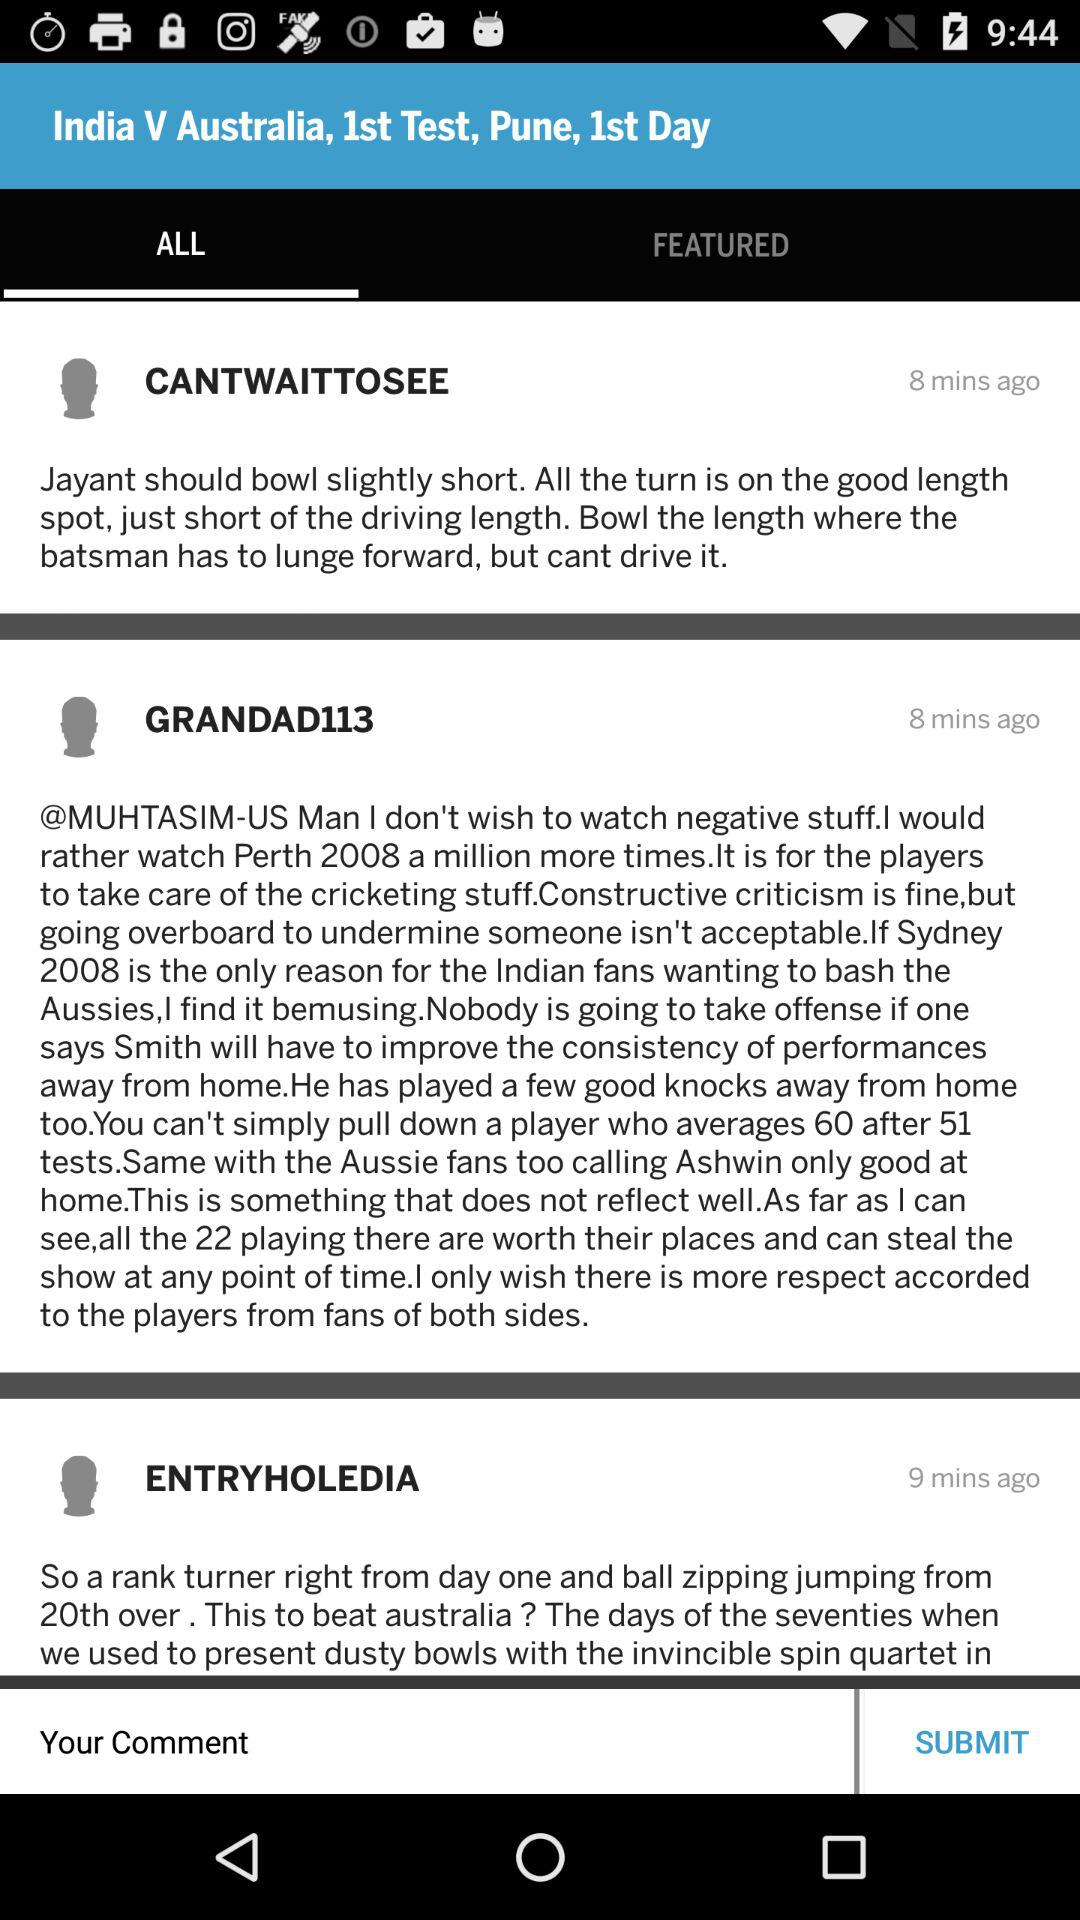What is the profile name?
When the provided information is insufficient, respond with <no answer>. <no answer> 